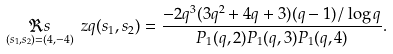<formula> <loc_0><loc_0><loc_500><loc_500>\underset { ( s _ { 1 } , s _ { 2 } ) = ( 4 , - 4 ) } { \Re s } \ z q ( s _ { 1 } , s _ { 2 } ) = \frac { - 2 q ^ { 3 } ( 3 q ^ { 2 } + 4 q + 3 ) ( q - 1 ) / \log q } { P _ { 1 } ( q , 2 ) P _ { 1 } ( q , 3 ) P _ { 1 } ( q , 4 ) } .</formula> 